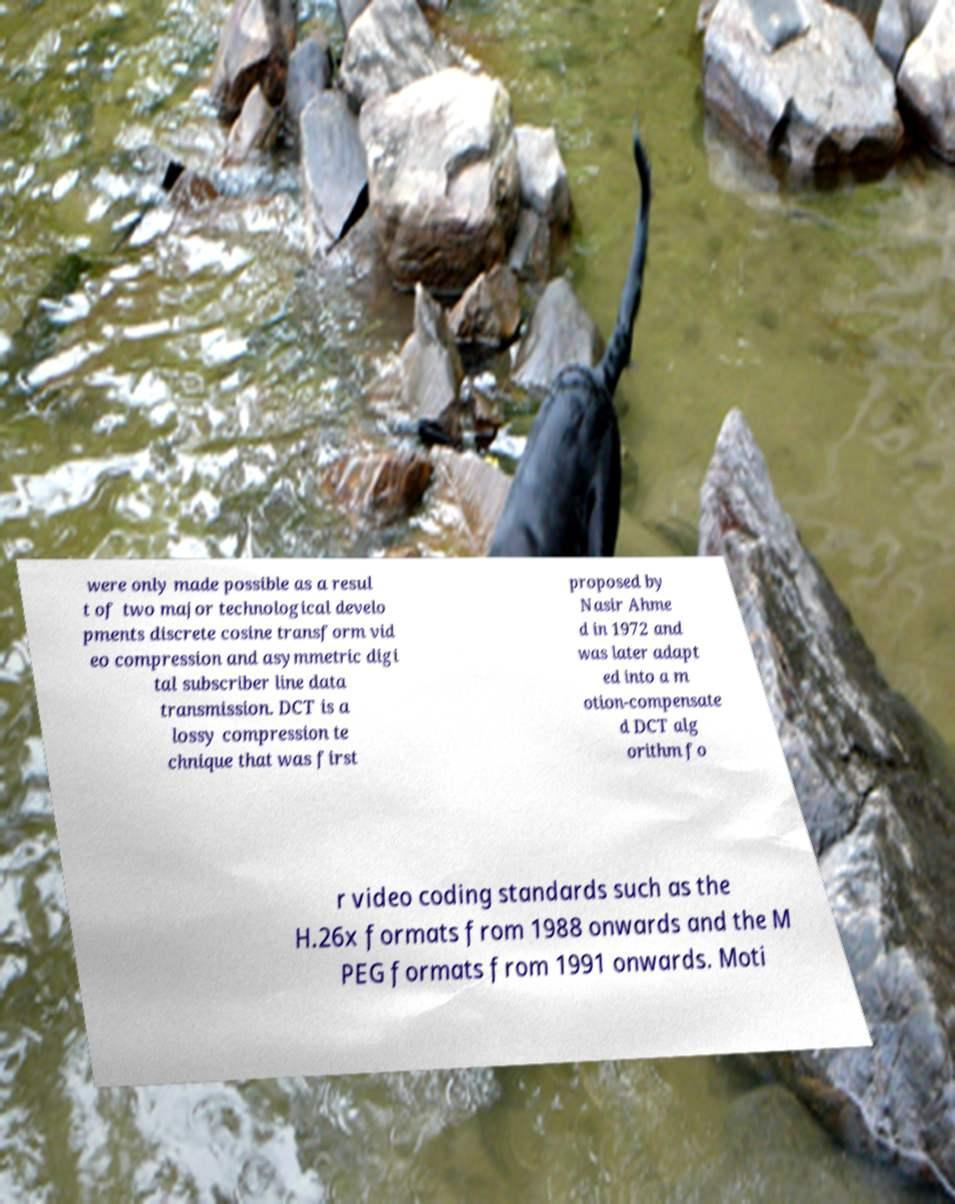Could you assist in decoding the text presented in this image and type it out clearly? were only made possible as a resul t of two major technological develo pments discrete cosine transform vid eo compression and asymmetric digi tal subscriber line data transmission. DCT is a lossy compression te chnique that was first proposed by Nasir Ahme d in 1972 and was later adapt ed into a m otion-compensate d DCT alg orithm fo r video coding standards such as the H.26x formats from 1988 onwards and the M PEG formats from 1991 onwards. Moti 